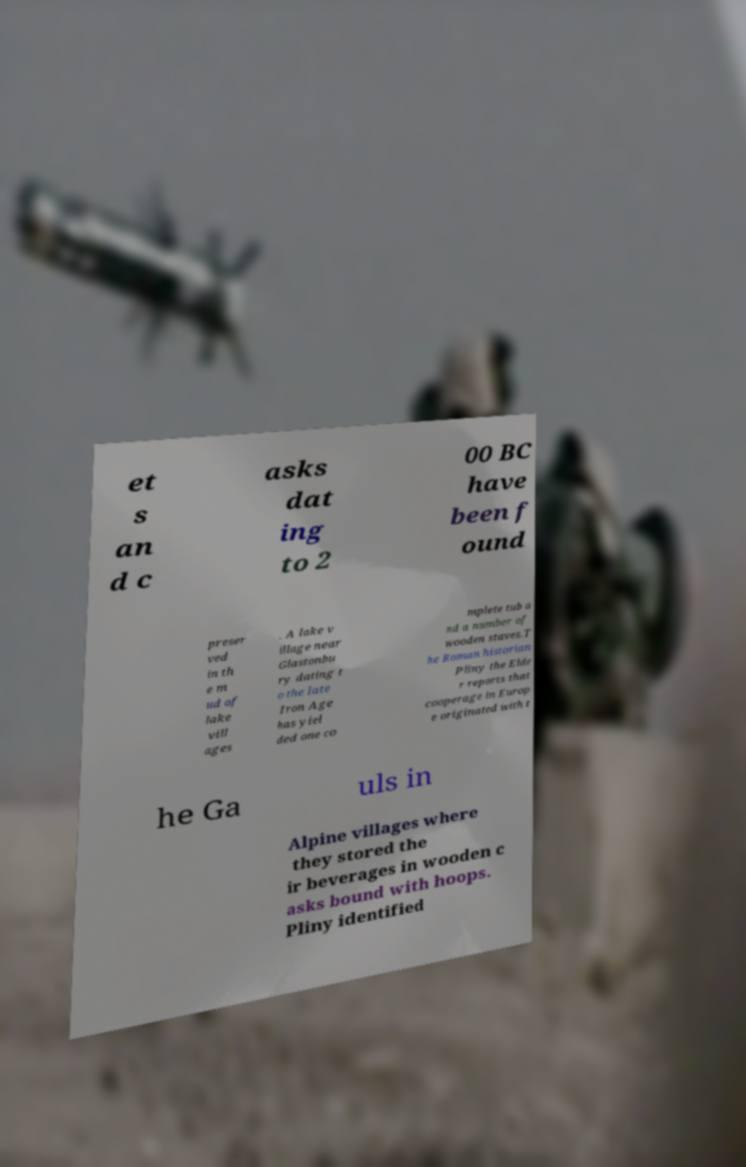Can you read and provide the text displayed in the image?This photo seems to have some interesting text. Can you extract and type it out for me? et s an d c asks dat ing to 2 00 BC have been f ound preser ved in th e m ud of lake vill ages . A lake v illage near Glastonbu ry dating t o the late Iron Age has yiel ded one co mplete tub a nd a number of wooden staves.T he Roman historian Pliny the Elde r reports that cooperage in Europ e originated with t he Ga uls in Alpine villages where they stored the ir beverages in wooden c asks bound with hoops. Pliny identified 